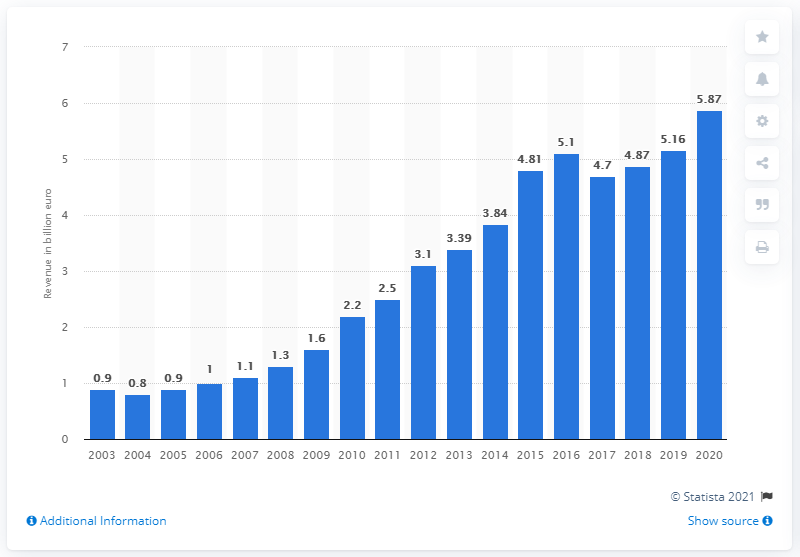Draw attention to some important aspects in this diagram. The Lego Group's revenue in 2020 was 5.87 billion USD. 